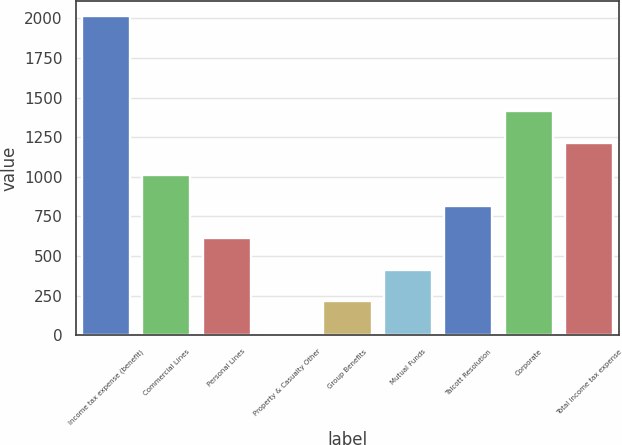<chart> <loc_0><loc_0><loc_500><loc_500><bar_chart><fcel>Income tax expense (benefit)<fcel>Commercial Lines<fcel>Personal Lines<fcel>Property & Casualty Other<fcel>Group Benefits<fcel>Mutual Funds<fcel>Talcott Resolution<fcel>Corporate<fcel>Total income tax expense<nl><fcel>2012<fcel>1013<fcel>613.4<fcel>14<fcel>213.8<fcel>413.6<fcel>813.2<fcel>1412.6<fcel>1212.8<nl></chart> 